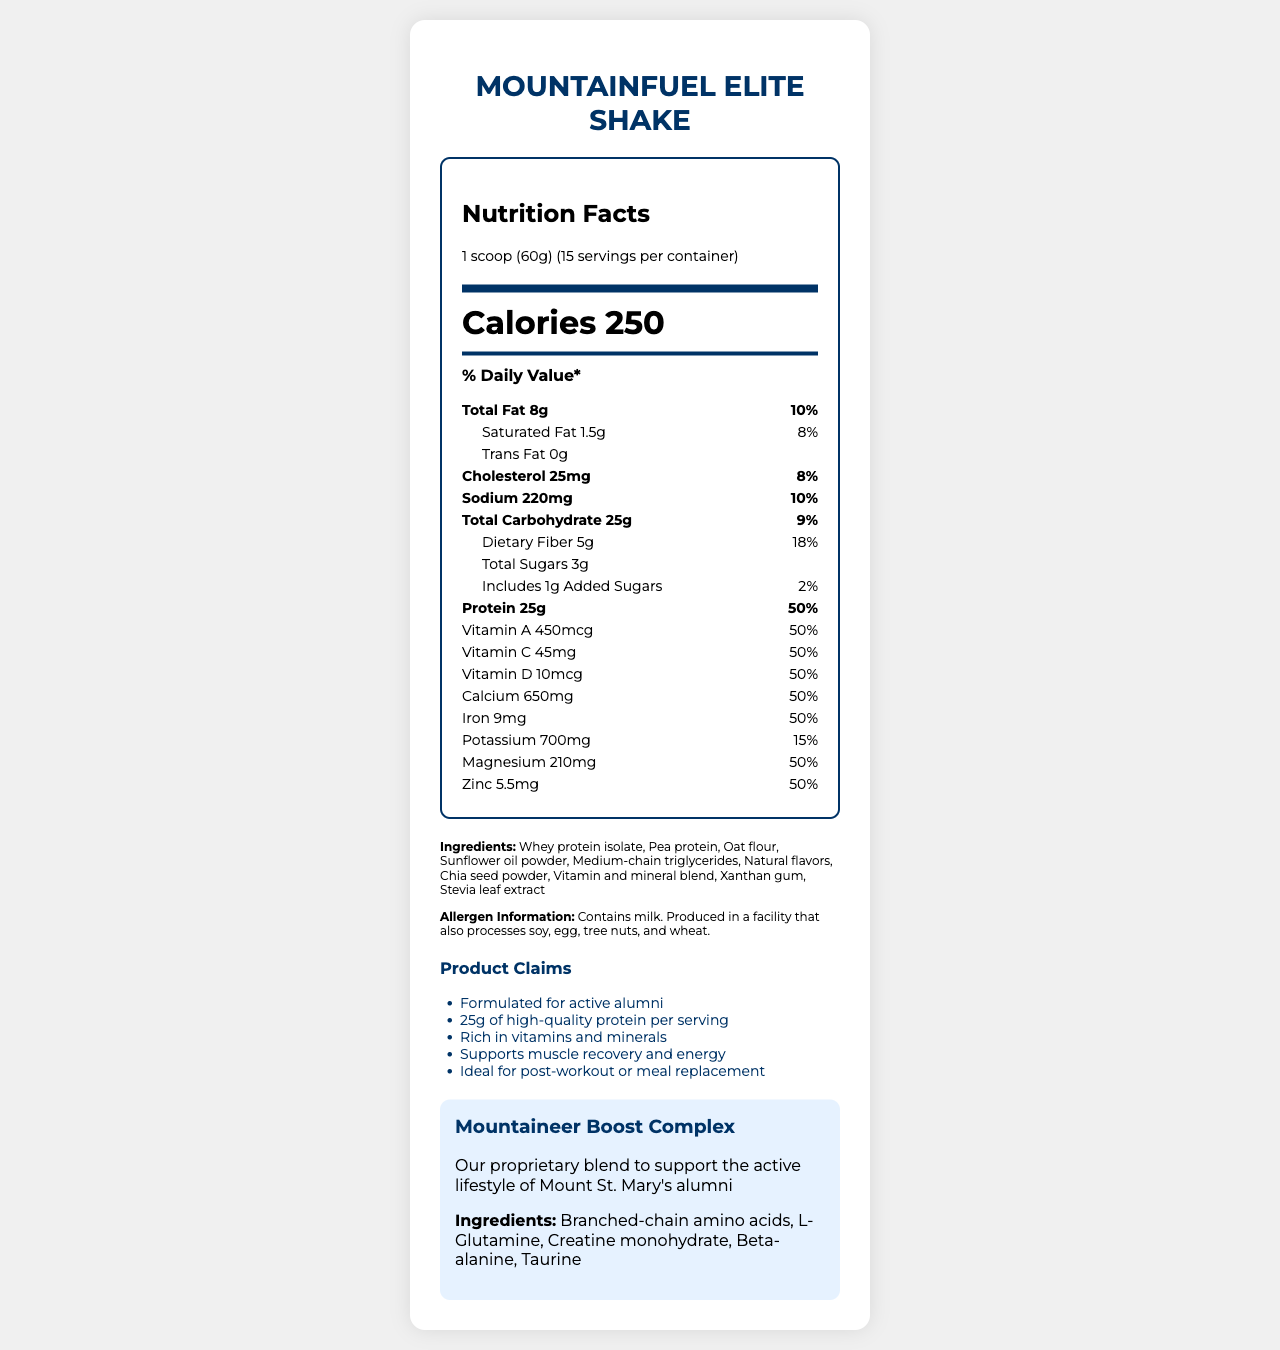what is the serving size for the MountainFuel Elite Shake? The serving size is stated at the beginning of the nutrition information under the heading "Nutrition Facts."
Answer: 1 scoop (60g) how many servings are there per container? The number of servings per container is specified near the top under the heading "Nutrition Facts."
Answer: 15 what is the total amount of protein in one serving? The protein amount is listed under the nutrition information section as "Protein 25g."
Answer: 25g what vitamins are provided at 50% daily value per serving of MountainFuel Elite Shake? All these vitamins and minerals show a daily value percentage of 50% next to their respective amounts in the nutrition information.
Answer: Vitamin A, Vitamin C, Vitamin D, Calcium, Iron, Magnesium, and Zinc how many grams of dietary fiber are in one serving? The dietary fiber amount is listed under the nutrition information section as "Dietary Fiber 5g."
Answer: 5g what are the main allergens in the MountainFuel Elite Shake? The allergen information specifies that the product contains milk and is produced in a facility that processes soy, egg, tree nuts, and wheat.
Answer: Milk which ingredient is not listed in the Mountaineer Boost Complex? A. Branched-chain amino acids B. L-Glutamine C. Chia seed powder D. Creatine monohydrate Chia seed powder is listed among the main ingredients, not part of the Mountaineer Boost Complex.
Answer: C. Chia seed powder what is the total amount of calories in one serving of MountainFuel Elite Shake? The caloric content is prominently displayed under the nutrition label as "Calories 250."
Answer: 250 calories how much saturated fat is in one serving? The amount of saturated fat is listed separately under total fat in the nutrition information section.
Answer: 1.5g which nutrient has the highest daily value percentage in one serving? A. Protein B. Sodium C. Vitamin C D. Total Carbohydrate Protein has a daily value percentage of 50%, which is the highest among the listed options.
Answer: A. Protein is the MountainFuel Elite Shake a good source of dietary fiber? With 5g of dietary fiber per serving making up 18% of the daily value, it is considered a good source of dietary fiber.
Answer: Yes describe the main purpose of the MountainFuel Elite Shake as stated in the document. The document describes MountainFuel Elite Shake as a convenient, nutrient-rich option for active individuals, particularly aimed at college alumni balancing busy schedules. It highlights the shake's nutritional benefits, including significant protein content and a blend of essential vitamins and minerals, emphasizing its role in muscle recovery and overall energy support.
Answer: MountainFuel Elite Shake is designed as a nutrient-dense meal replacement shake tailored for busy college alumni maintaining an active lifestyle. It contains high protein content, essential vitamins, and minerals to support muscle recovery and energy and is ideal for post-workout recovery or quick meal replacements. what is the sugar content in one serving of MountainFuel Elite Shake? The sugar content is listed under total carbohydrate in the nutrition information section as "Total Sugars 3g" and additionally clarifies "Includes 1g Added Sugars."
Answer: 3g, including 1g of added sugars how much potassium is provided in one serving? The potassium amount is listed with its corresponding daily value next to protein in the nutrition information section.
Answer: 700mg can you determine the price of the MountainFuel Elite Shake from the document? The price information is not provided in the document. The document focuses on nutritional information and ingredients.
Answer: Cannot be determined 